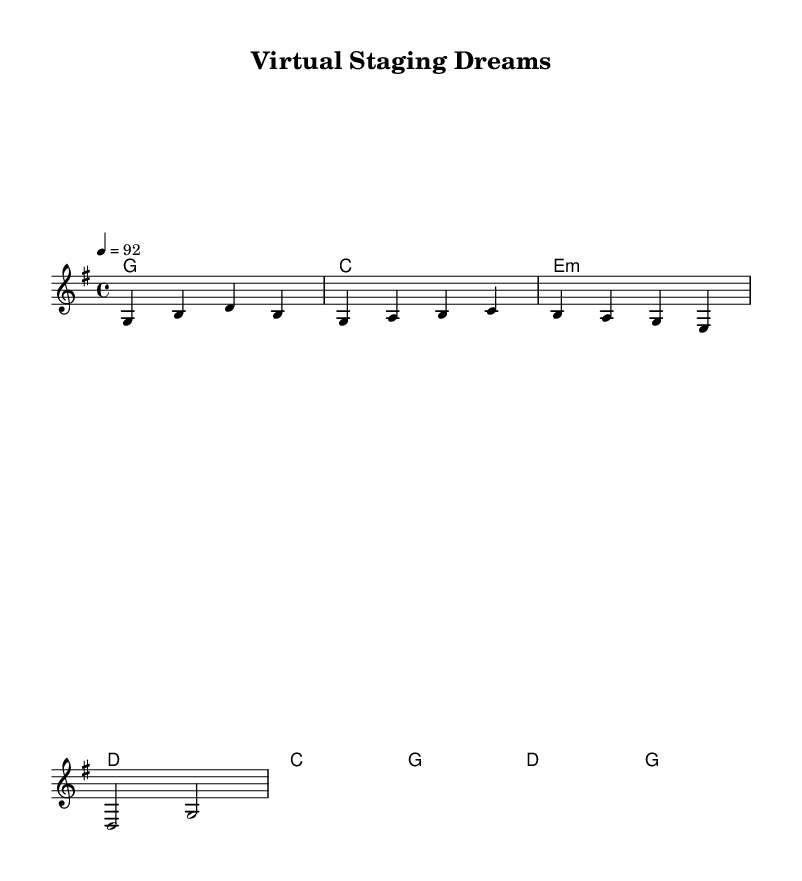What is the key signature of this music? The key signature is G major, which has one sharp (F#) indicated at the beginning of the score.
Answer: G major What is the time signature of this music? The time signature is indicated as 4/4, meaning there are four beats per measure and the quarter note receives one beat.
Answer: 4/4 What is the tempo marking of this piece? The tempo marking states "4 = 92," indicating that there are 92 beats per minute (BPM) with a quarter note representing one beat.
Answer: 92 What is the first word of the verse lyrics? The lyrics begin with "Emp," indicating a focus on empty houses as a theme in the song.
Answer: Emp How many measures are in the melody section? The melody section contains four measures based on the notation provided, which can be counted from the beginning to the end of the melody line.
Answer: 4 What type of song structure is used in this piece? The song structure alternates between verses and a chorus, which is a common structure for country songs, emphasizing storytelling and reflective themes.
Answer: Verse-Chorus 